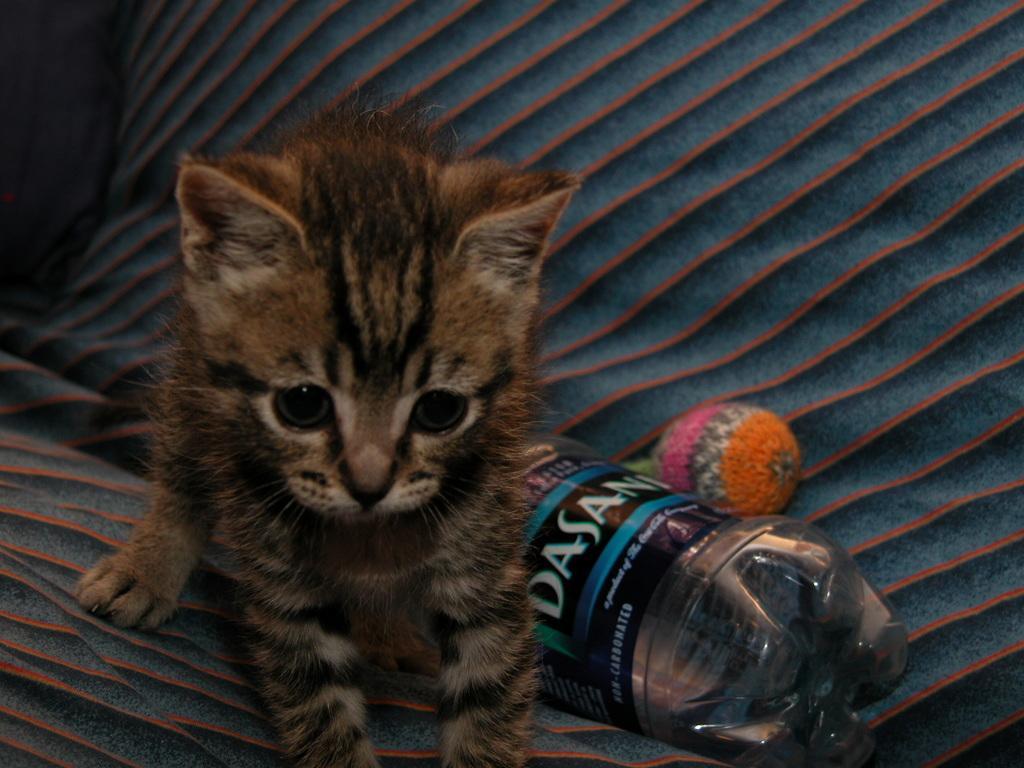Describe this image in one or two sentences. In this picture we can see a cat and there is a bottle beside her 